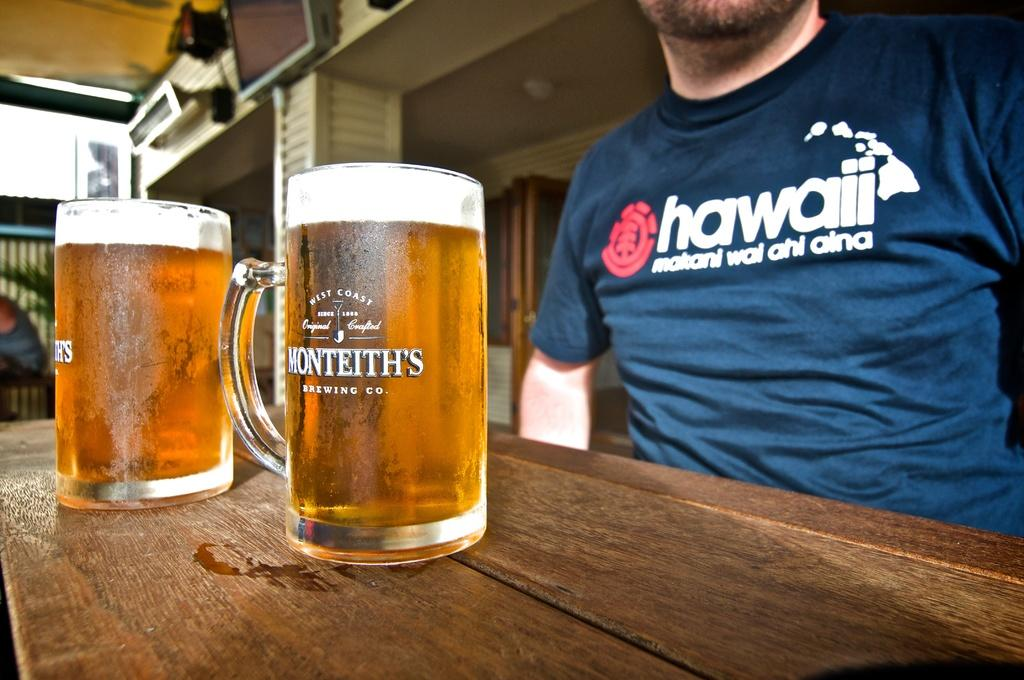<image>
Share a concise interpretation of the image provided. A man wearing a shirt that is from Hawaii 